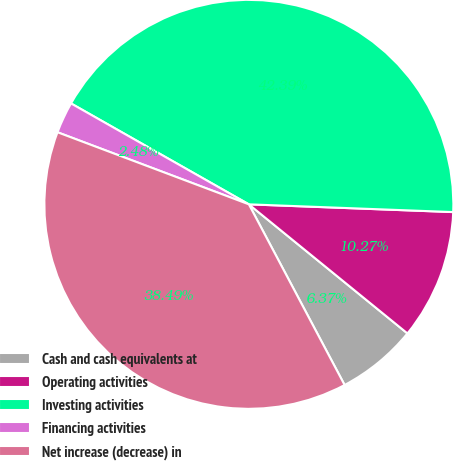Convert chart to OTSL. <chart><loc_0><loc_0><loc_500><loc_500><pie_chart><fcel>Cash and cash equivalents at<fcel>Operating activities<fcel>Investing activities<fcel>Financing activities<fcel>Net increase (decrease) in<nl><fcel>6.37%<fcel>10.27%<fcel>42.39%<fcel>2.48%<fcel>38.49%<nl></chart> 